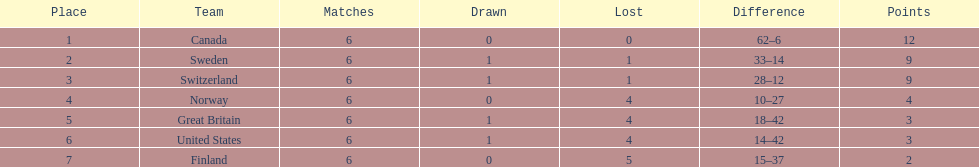How many teams secured 6 wins? 1. 